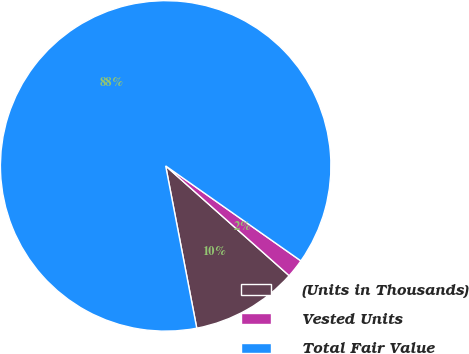<chart> <loc_0><loc_0><loc_500><loc_500><pie_chart><fcel>(Units in Thousands)<fcel>Vested Units<fcel>Total Fair Value<nl><fcel>10.42%<fcel>1.82%<fcel>87.76%<nl></chart> 